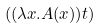Convert formula to latex. <formula><loc_0><loc_0><loc_500><loc_500>( ( \lambda x . A ( x ) ) t )</formula> 